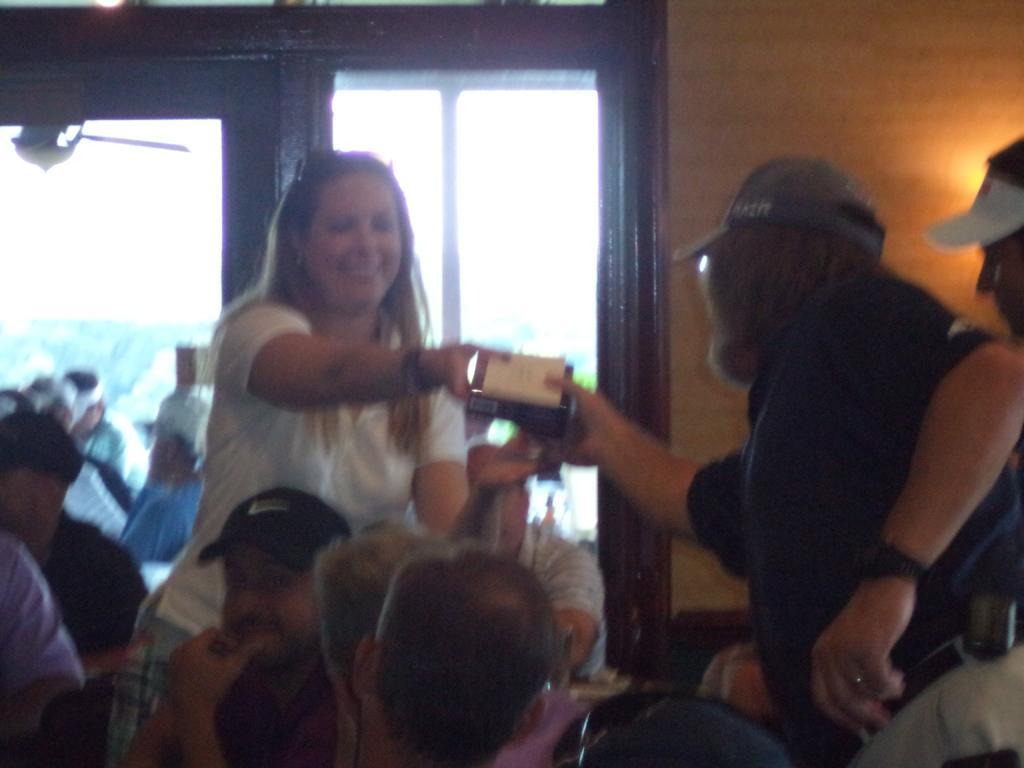Please provide a concise description of this image. In this image we can see a few people, among them some are sitting and some people are standing and holding objects, in the background we can see a window and the wall. 